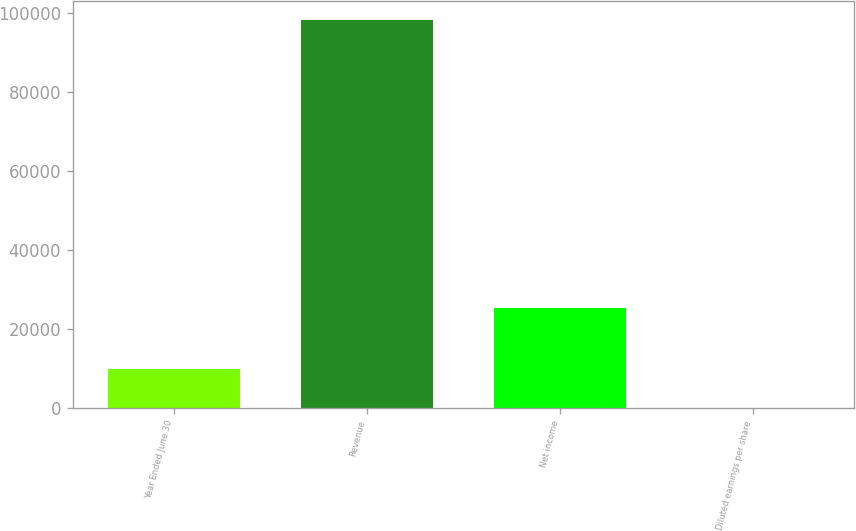Convert chart. <chart><loc_0><loc_0><loc_500><loc_500><bar_chart><fcel>Year Ended June 30<fcel>Revenue<fcel>Net income<fcel>Diluted earnings per share<nl><fcel>9831.99<fcel>98291<fcel>25179<fcel>3.21<nl></chart> 